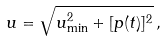Convert formula to latex. <formula><loc_0><loc_0><loc_500><loc_500>u = \sqrt { u _ { \min } ^ { 2 } + [ p ( t ) ] ^ { 2 } } \, ,</formula> 